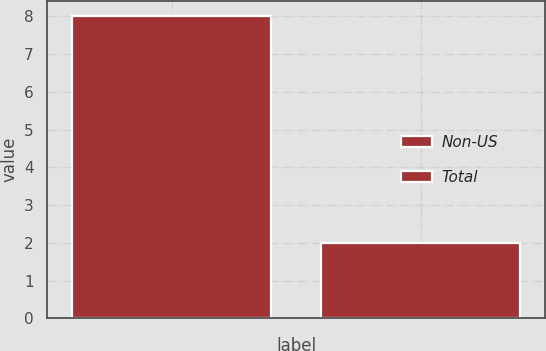<chart> <loc_0><loc_0><loc_500><loc_500><bar_chart><fcel>Non-US<fcel>Total<nl><fcel>8<fcel>2<nl></chart> 